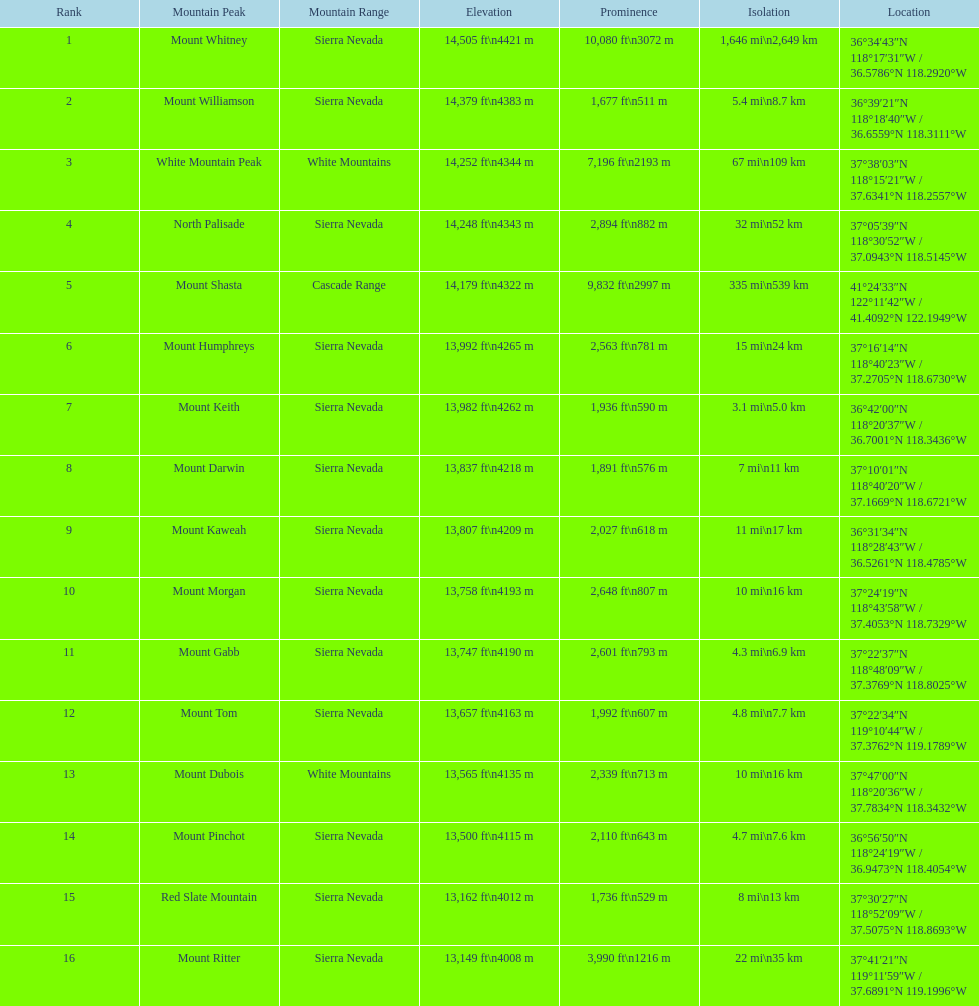What is the loftiest peak in the sierra nevadas? Mount Whitney. 